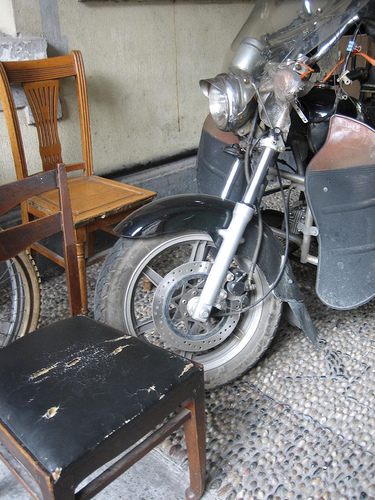<image>What is the name of the brown chair's style? I don't know the name of the brown chair's style. It can be 'antique', 'dining', 'art deco', 'mission', 'wood', 'colonial', or 'rustic'. What is the name of the brown chair's style? I don't know the name of the brown chair's style. It can be 'antique', 'dining', 'art deco', 'mission', 'colonial', or 'rustic'. 